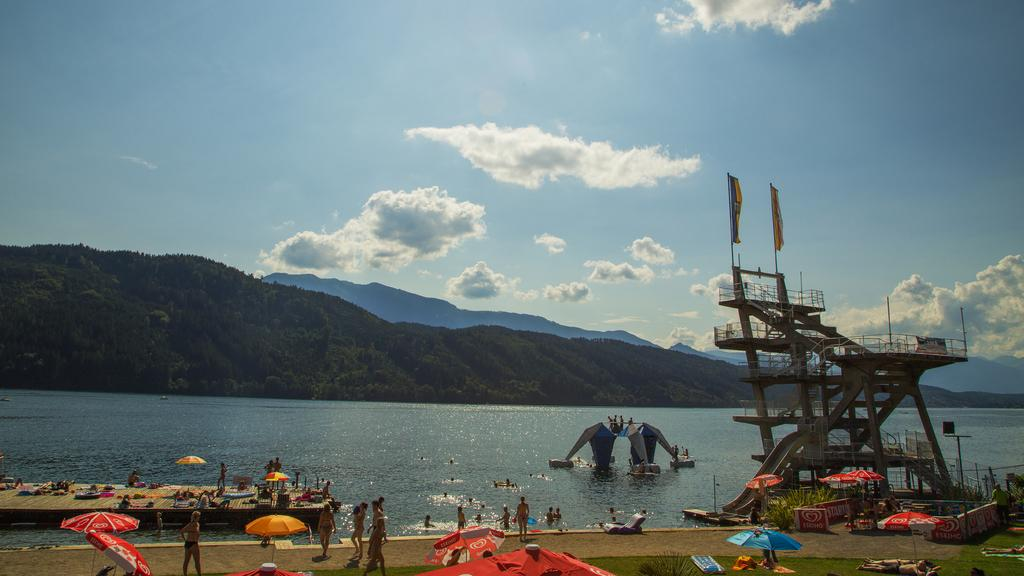What type of vehicles can be seen in the image? There are boats in the image. What else is present in the water besides the boats? There are objects in the water. Can you identify any people in the image? Yes, there are people visible in the image. What might the people be using to protect themselves from the sun or rain? Umbrellas are present in the image. What type of landscape can be seen in the background? There are hills visible in the image. What type of farm animals can be seen grazing in the image? There is no farm or farm animals present in the image. What type of flame can be seen in the image? There is no flame present in the image. 